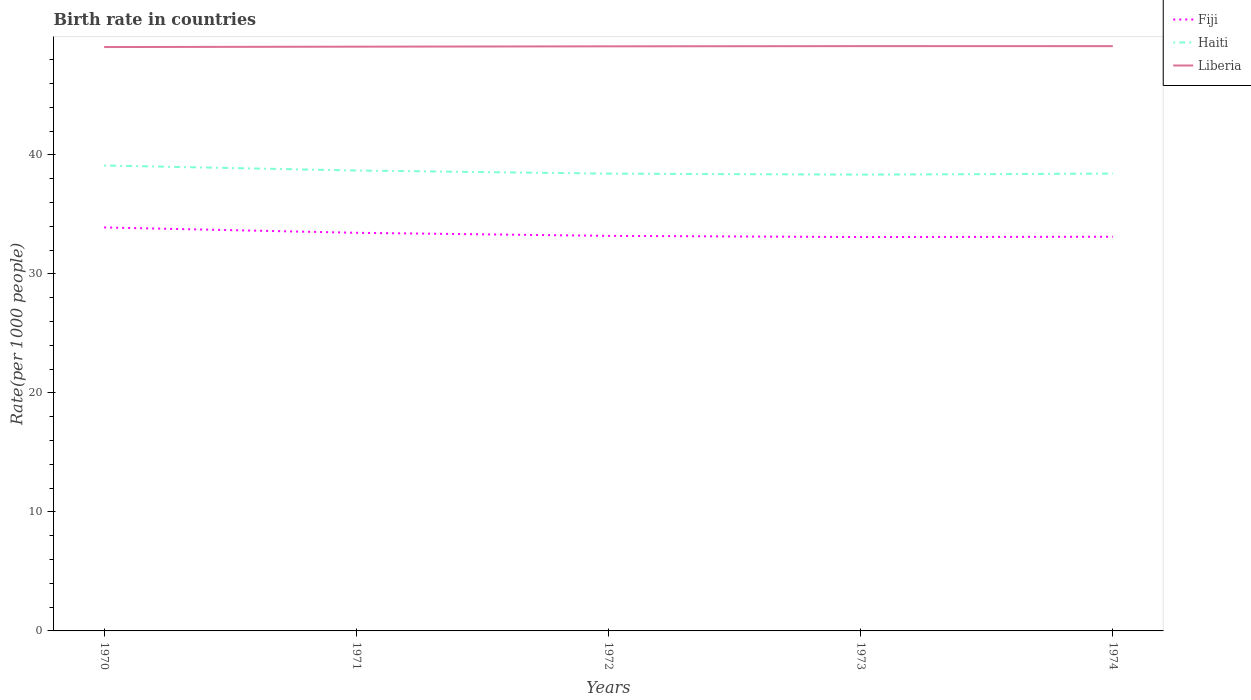Across all years, what is the maximum birth rate in Fiji?
Your answer should be very brief. 33.09. In which year was the birth rate in Liberia maximum?
Your answer should be very brief. 1970. What is the total birth rate in Fiji in the graph?
Give a very brief answer. 0.78. What is the difference between the highest and the second highest birth rate in Haiti?
Ensure brevity in your answer.  0.77. Is the birth rate in Fiji strictly greater than the birth rate in Liberia over the years?
Offer a very short reply. Yes. How many lines are there?
Your response must be concise. 3. How many years are there in the graph?
Your answer should be compact. 5. What is the difference between two consecutive major ticks on the Y-axis?
Your answer should be compact. 10. Are the values on the major ticks of Y-axis written in scientific E-notation?
Provide a succinct answer. No. Does the graph contain grids?
Provide a short and direct response. No. What is the title of the graph?
Offer a terse response. Birth rate in countries. Does "Bangladesh" appear as one of the legend labels in the graph?
Your answer should be very brief. No. What is the label or title of the X-axis?
Provide a short and direct response. Years. What is the label or title of the Y-axis?
Your answer should be very brief. Rate(per 1000 people). What is the Rate(per 1000 people) in Fiji in 1970?
Offer a terse response. 33.9. What is the Rate(per 1000 people) in Haiti in 1970?
Your answer should be very brief. 39.1. What is the Rate(per 1000 people) in Liberia in 1970?
Your response must be concise. 49.05. What is the Rate(per 1000 people) of Fiji in 1971?
Provide a succinct answer. 33.45. What is the Rate(per 1000 people) of Haiti in 1971?
Give a very brief answer. 38.68. What is the Rate(per 1000 people) of Liberia in 1971?
Provide a succinct answer. 49.09. What is the Rate(per 1000 people) in Fiji in 1972?
Your response must be concise. 33.19. What is the Rate(per 1000 people) in Haiti in 1972?
Keep it short and to the point. 38.42. What is the Rate(per 1000 people) in Liberia in 1972?
Your answer should be compact. 49.12. What is the Rate(per 1000 people) in Fiji in 1973?
Your answer should be very brief. 33.09. What is the Rate(per 1000 people) of Haiti in 1973?
Your answer should be very brief. 38.33. What is the Rate(per 1000 people) of Liberia in 1973?
Provide a succinct answer. 49.13. What is the Rate(per 1000 people) in Fiji in 1974?
Your answer should be compact. 33.12. What is the Rate(per 1000 people) in Haiti in 1974?
Provide a succinct answer. 38.42. What is the Rate(per 1000 people) in Liberia in 1974?
Your response must be concise. 49.13. Across all years, what is the maximum Rate(per 1000 people) of Fiji?
Keep it short and to the point. 33.9. Across all years, what is the maximum Rate(per 1000 people) in Haiti?
Provide a short and direct response. 39.1. Across all years, what is the maximum Rate(per 1000 people) of Liberia?
Offer a terse response. 49.13. Across all years, what is the minimum Rate(per 1000 people) in Fiji?
Give a very brief answer. 33.09. Across all years, what is the minimum Rate(per 1000 people) of Haiti?
Provide a short and direct response. 38.33. Across all years, what is the minimum Rate(per 1000 people) in Liberia?
Offer a very short reply. 49.05. What is the total Rate(per 1000 people) in Fiji in the graph?
Make the answer very short. 166.75. What is the total Rate(per 1000 people) of Haiti in the graph?
Offer a terse response. 192.96. What is the total Rate(per 1000 people) in Liberia in the graph?
Your response must be concise. 245.52. What is the difference between the Rate(per 1000 people) of Fiji in 1970 and that in 1971?
Your answer should be compact. 0.45. What is the difference between the Rate(per 1000 people) in Haiti in 1970 and that in 1971?
Offer a very short reply. 0.42. What is the difference between the Rate(per 1000 people) in Liberia in 1970 and that in 1971?
Your answer should be compact. -0.03. What is the difference between the Rate(per 1000 people) of Fiji in 1970 and that in 1972?
Offer a terse response. 0.71. What is the difference between the Rate(per 1000 people) in Haiti in 1970 and that in 1972?
Offer a terse response. 0.68. What is the difference between the Rate(per 1000 people) in Liberia in 1970 and that in 1972?
Provide a short and direct response. -0.06. What is the difference between the Rate(per 1000 people) in Fiji in 1970 and that in 1973?
Make the answer very short. 0.81. What is the difference between the Rate(per 1000 people) in Haiti in 1970 and that in 1973?
Make the answer very short. 0.77. What is the difference between the Rate(per 1000 people) in Liberia in 1970 and that in 1973?
Your response must be concise. -0.08. What is the difference between the Rate(per 1000 people) of Fiji in 1970 and that in 1974?
Give a very brief answer. 0.78. What is the difference between the Rate(per 1000 people) of Haiti in 1970 and that in 1974?
Ensure brevity in your answer.  0.68. What is the difference between the Rate(per 1000 people) in Liberia in 1970 and that in 1974?
Offer a terse response. -0.08. What is the difference between the Rate(per 1000 people) in Fiji in 1971 and that in 1972?
Offer a very short reply. 0.26. What is the difference between the Rate(per 1000 people) of Haiti in 1971 and that in 1972?
Provide a short and direct response. 0.26. What is the difference between the Rate(per 1000 people) in Liberia in 1971 and that in 1972?
Keep it short and to the point. -0.03. What is the difference between the Rate(per 1000 people) in Fiji in 1971 and that in 1973?
Your answer should be very brief. 0.36. What is the difference between the Rate(per 1000 people) of Haiti in 1971 and that in 1973?
Give a very brief answer. 0.35. What is the difference between the Rate(per 1000 people) in Liberia in 1971 and that in 1973?
Your answer should be compact. -0.05. What is the difference between the Rate(per 1000 people) in Fiji in 1971 and that in 1974?
Give a very brief answer. 0.33. What is the difference between the Rate(per 1000 people) of Haiti in 1971 and that in 1974?
Provide a succinct answer. 0.26. What is the difference between the Rate(per 1000 people) in Liberia in 1971 and that in 1974?
Keep it short and to the point. -0.04. What is the difference between the Rate(per 1000 people) of Fiji in 1972 and that in 1973?
Your response must be concise. 0.1. What is the difference between the Rate(per 1000 people) in Haiti in 1972 and that in 1973?
Give a very brief answer. 0.09. What is the difference between the Rate(per 1000 people) in Liberia in 1972 and that in 1973?
Your response must be concise. -0.02. What is the difference between the Rate(per 1000 people) of Fiji in 1972 and that in 1974?
Provide a short and direct response. 0.07. What is the difference between the Rate(per 1000 people) in Haiti in 1972 and that in 1974?
Provide a short and direct response. -0. What is the difference between the Rate(per 1000 people) in Liberia in 1972 and that in 1974?
Your answer should be very brief. -0.01. What is the difference between the Rate(per 1000 people) of Fiji in 1973 and that in 1974?
Provide a short and direct response. -0.03. What is the difference between the Rate(per 1000 people) of Haiti in 1973 and that in 1974?
Your answer should be compact. -0.09. What is the difference between the Rate(per 1000 people) of Liberia in 1973 and that in 1974?
Offer a terse response. 0. What is the difference between the Rate(per 1000 people) in Fiji in 1970 and the Rate(per 1000 people) in Haiti in 1971?
Offer a terse response. -4.78. What is the difference between the Rate(per 1000 people) of Fiji in 1970 and the Rate(per 1000 people) of Liberia in 1971?
Your answer should be compact. -15.19. What is the difference between the Rate(per 1000 people) in Haiti in 1970 and the Rate(per 1000 people) in Liberia in 1971?
Your response must be concise. -9.98. What is the difference between the Rate(per 1000 people) in Fiji in 1970 and the Rate(per 1000 people) in Haiti in 1972?
Ensure brevity in your answer.  -4.52. What is the difference between the Rate(per 1000 people) of Fiji in 1970 and the Rate(per 1000 people) of Liberia in 1972?
Your answer should be very brief. -15.22. What is the difference between the Rate(per 1000 people) in Haiti in 1970 and the Rate(per 1000 people) in Liberia in 1972?
Offer a terse response. -10.01. What is the difference between the Rate(per 1000 people) in Fiji in 1970 and the Rate(per 1000 people) in Haiti in 1973?
Offer a terse response. -4.43. What is the difference between the Rate(per 1000 people) in Fiji in 1970 and the Rate(per 1000 people) in Liberia in 1973?
Offer a terse response. -15.23. What is the difference between the Rate(per 1000 people) of Haiti in 1970 and the Rate(per 1000 people) of Liberia in 1973?
Give a very brief answer. -10.03. What is the difference between the Rate(per 1000 people) in Fiji in 1970 and the Rate(per 1000 people) in Haiti in 1974?
Offer a terse response. -4.53. What is the difference between the Rate(per 1000 people) of Fiji in 1970 and the Rate(per 1000 people) of Liberia in 1974?
Ensure brevity in your answer.  -15.23. What is the difference between the Rate(per 1000 people) in Haiti in 1970 and the Rate(per 1000 people) in Liberia in 1974?
Offer a terse response. -10.03. What is the difference between the Rate(per 1000 people) in Fiji in 1971 and the Rate(per 1000 people) in Haiti in 1972?
Your answer should be compact. -4.97. What is the difference between the Rate(per 1000 people) in Fiji in 1971 and the Rate(per 1000 people) in Liberia in 1972?
Your answer should be very brief. -15.67. What is the difference between the Rate(per 1000 people) of Haiti in 1971 and the Rate(per 1000 people) of Liberia in 1972?
Offer a terse response. -10.43. What is the difference between the Rate(per 1000 people) in Fiji in 1971 and the Rate(per 1000 people) in Haiti in 1973?
Provide a succinct answer. -4.88. What is the difference between the Rate(per 1000 people) of Fiji in 1971 and the Rate(per 1000 people) of Liberia in 1973?
Your answer should be compact. -15.68. What is the difference between the Rate(per 1000 people) in Haiti in 1971 and the Rate(per 1000 people) in Liberia in 1973?
Your answer should be compact. -10.45. What is the difference between the Rate(per 1000 people) in Fiji in 1971 and the Rate(per 1000 people) in Haiti in 1974?
Provide a short and direct response. -4.97. What is the difference between the Rate(per 1000 people) in Fiji in 1971 and the Rate(per 1000 people) in Liberia in 1974?
Provide a short and direct response. -15.68. What is the difference between the Rate(per 1000 people) of Haiti in 1971 and the Rate(per 1000 people) of Liberia in 1974?
Keep it short and to the point. -10.45. What is the difference between the Rate(per 1000 people) in Fiji in 1972 and the Rate(per 1000 people) in Haiti in 1973?
Give a very brief answer. -5.14. What is the difference between the Rate(per 1000 people) of Fiji in 1972 and the Rate(per 1000 people) of Liberia in 1973?
Your response must be concise. -15.94. What is the difference between the Rate(per 1000 people) in Haiti in 1972 and the Rate(per 1000 people) in Liberia in 1973?
Your answer should be compact. -10.71. What is the difference between the Rate(per 1000 people) of Fiji in 1972 and the Rate(per 1000 people) of Haiti in 1974?
Provide a short and direct response. -5.23. What is the difference between the Rate(per 1000 people) of Fiji in 1972 and the Rate(per 1000 people) of Liberia in 1974?
Offer a very short reply. -15.94. What is the difference between the Rate(per 1000 people) of Haiti in 1972 and the Rate(per 1000 people) of Liberia in 1974?
Ensure brevity in your answer.  -10.71. What is the difference between the Rate(per 1000 people) in Fiji in 1973 and the Rate(per 1000 people) in Haiti in 1974?
Offer a very short reply. -5.33. What is the difference between the Rate(per 1000 people) in Fiji in 1973 and the Rate(per 1000 people) in Liberia in 1974?
Keep it short and to the point. -16.04. What is the difference between the Rate(per 1000 people) of Haiti in 1973 and the Rate(per 1000 people) of Liberia in 1974?
Keep it short and to the point. -10.8. What is the average Rate(per 1000 people) of Fiji per year?
Keep it short and to the point. 33.35. What is the average Rate(per 1000 people) of Haiti per year?
Provide a short and direct response. 38.59. What is the average Rate(per 1000 people) in Liberia per year?
Provide a succinct answer. 49.1. In the year 1970, what is the difference between the Rate(per 1000 people) in Fiji and Rate(per 1000 people) in Haiti?
Offer a terse response. -5.21. In the year 1970, what is the difference between the Rate(per 1000 people) in Fiji and Rate(per 1000 people) in Liberia?
Offer a terse response. -15.16. In the year 1970, what is the difference between the Rate(per 1000 people) of Haiti and Rate(per 1000 people) of Liberia?
Your answer should be compact. -9.95. In the year 1971, what is the difference between the Rate(per 1000 people) in Fiji and Rate(per 1000 people) in Haiti?
Offer a very short reply. -5.23. In the year 1971, what is the difference between the Rate(per 1000 people) of Fiji and Rate(per 1000 people) of Liberia?
Your answer should be very brief. -15.64. In the year 1971, what is the difference between the Rate(per 1000 people) of Haiti and Rate(per 1000 people) of Liberia?
Your answer should be compact. -10.4. In the year 1972, what is the difference between the Rate(per 1000 people) of Fiji and Rate(per 1000 people) of Haiti?
Provide a short and direct response. -5.23. In the year 1972, what is the difference between the Rate(per 1000 people) of Fiji and Rate(per 1000 people) of Liberia?
Provide a succinct answer. -15.92. In the year 1972, what is the difference between the Rate(per 1000 people) of Haiti and Rate(per 1000 people) of Liberia?
Make the answer very short. -10.7. In the year 1973, what is the difference between the Rate(per 1000 people) of Fiji and Rate(per 1000 people) of Haiti?
Ensure brevity in your answer.  -5.24. In the year 1973, what is the difference between the Rate(per 1000 people) of Fiji and Rate(per 1000 people) of Liberia?
Your answer should be very brief. -16.04. In the year 1973, what is the difference between the Rate(per 1000 people) in Haiti and Rate(per 1000 people) in Liberia?
Provide a short and direct response. -10.8. In the year 1974, what is the difference between the Rate(per 1000 people) in Fiji and Rate(per 1000 people) in Haiti?
Your answer should be compact. -5.31. In the year 1974, what is the difference between the Rate(per 1000 people) of Fiji and Rate(per 1000 people) of Liberia?
Provide a succinct answer. -16.01. In the year 1974, what is the difference between the Rate(per 1000 people) of Haiti and Rate(per 1000 people) of Liberia?
Ensure brevity in your answer.  -10.71. What is the ratio of the Rate(per 1000 people) in Fiji in 1970 to that in 1971?
Make the answer very short. 1.01. What is the ratio of the Rate(per 1000 people) in Haiti in 1970 to that in 1971?
Your answer should be compact. 1.01. What is the ratio of the Rate(per 1000 people) in Fiji in 1970 to that in 1972?
Give a very brief answer. 1.02. What is the ratio of the Rate(per 1000 people) of Haiti in 1970 to that in 1972?
Ensure brevity in your answer.  1.02. What is the ratio of the Rate(per 1000 people) in Liberia in 1970 to that in 1972?
Your response must be concise. 1. What is the ratio of the Rate(per 1000 people) in Fiji in 1970 to that in 1973?
Ensure brevity in your answer.  1.02. What is the ratio of the Rate(per 1000 people) of Haiti in 1970 to that in 1973?
Your response must be concise. 1.02. What is the ratio of the Rate(per 1000 people) of Fiji in 1970 to that in 1974?
Give a very brief answer. 1.02. What is the ratio of the Rate(per 1000 people) in Haiti in 1970 to that in 1974?
Make the answer very short. 1.02. What is the ratio of the Rate(per 1000 people) of Fiji in 1971 to that in 1972?
Your answer should be compact. 1.01. What is the ratio of the Rate(per 1000 people) of Haiti in 1971 to that in 1972?
Your answer should be very brief. 1.01. What is the ratio of the Rate(per 1000 people) of Fiji in 1971 to that in 1973?
Offer a terse response. 1.01. What is the ratio of the Rate(per 1000 people) in Haiti in 1971 to that in 1973?
Keep it short and to the point. 1.01. What is the ratio of the Rate(per 1000 people) in Liberia in 1971 to that in 1973?
Your answer should be very brief. 1. What is the ratio of the Rate(per 1000 people) in Fiji in 1971 to that in 1974?
Offer a very short reply. 1.01. What is the ratio of the Rate(per 1000 people) of Liberia in 1971 to that in 1974?
Your answer should be compact. 1. What is the ratio of the Rate(per 1000 people) in Haiti in 1972 to that in 1973?
Give a very brief answer. 1. What is the ratio of the Rate(per 1000 people) in Fiji in 1972 to that in 1974?
Provide a succinct answer. 1. What is the ratio of the Rate(per 1000 people) in Haiti in 1973 to that in 1974?
Give a very brief answer. 1. What is the ratio of the Rate(per 1000 people) of Liberia in 1973 to that in 1974?
Keep it short and to the point. 1. What is the difference between the highest and the second highest Rate(per 1000 people) in Fiji?
Give a very brief answer. 0.45. What is the difference between the highest and the second highest Rate(per 1000 people) of Haiti?
Keep it short and to the point. 0.42. What is the difference between the highest and the second highest Rate(per 1000 people) of Liberia?
Offer a very short reply. 0. What is the difference between the highest and the lowest Rate(per 1000 people) of Fiji?
Your response must be concise. 0.81. What is the difference between the highest and the lowest Rate(per 1000 people) in Haiti?
Provide a succinct answer. 0.77. What is the difference between the highest and the lowest Rate(per 1000 people) in Liberia?
Your response must be concise. 0.08. 